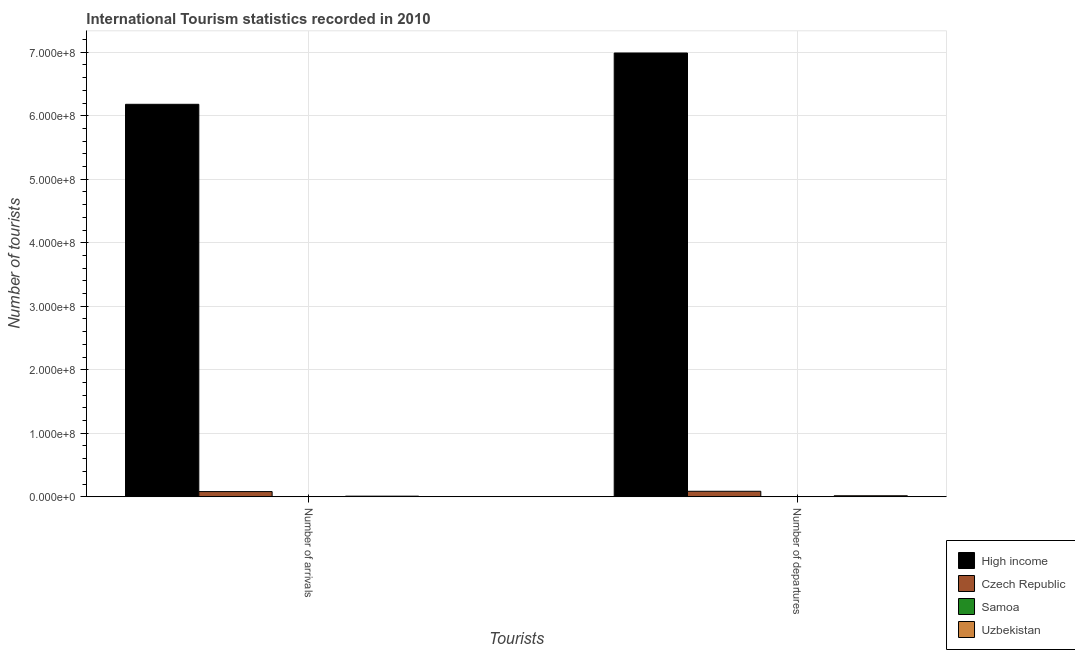Are the number of bars per tick equal to the number of legend labels?
Provide a short and direct response. Yes. How many bars are there on the 2nd tick from the right?
Ensure brevity in your answer.  4. What is the label of the 1st group of bars from the left?
Ensure brevity in your answer.  Number of arrivals. What is the number of tourist departures in High income?
Offer a very short reply. 6.99e+08. Across all countries, what is the maximum number of tourist arrivals?
Ensure brevity in your answer.  6.18e+08. Across all countries, what is the minimum number of tourist arrivals?
Provide a short and direct response. 1.22e+05. In which country was the number of tourist arrivals minimum?
Your answer should be compact. Samoa. What is the total number of tourist arrivals in the graph?
Make the answer very short. 6.27e+08. What is the difference between the number of tourist departures in Czech Republic and that in Uzbekistan?
Ensure brevity in your answer.  7.06e+06. What is the difference between the number of tourist arrivals in Czech Republic and the number of tourist departures in Uzbekistan?
Provide a succinct answer. 6.58e+06. What is the average number of tourist departures per country?
Offer a very short reply. 1.77e+08. What is the difference between the number of tourist departures and number of tourist arrivals in High income?
Provide a short and direct response. 8.08e+07. What is the ratio of the number of tourist departures in Samoa to that in High income?
Provide a short and direct response. 8.01308172830828e-5. Is the number of tourist arrivals in High income less than that in Czech Republic?
Give a very brief answer. No. What does the 4th bar from the left in Number of departures represents?
Keep it short and to the point. Uzbekistan. What does the 3rd bar from the right in Number of departures represents?
Your response must be concise. Czech Republic. How many bars are there?
Keep it short and to the point. 8. How many countries are there in the graph?
Make the answer very short. 4. Does the graph contain grids?
Offer a very short reply. Yes. Where does the legend appear in the graph?
Offer a very short reply. Bottom right. How many legend labels are there?
Ensure brevity in your answer.  4. How are the legend labels stacked?
Provide a succinct answer. Vertical. What is the title of the graph?
Provide a succinct answer. International Tourism statistics recorded in 2010. Does "Mongolia" appear as one of the legend labels in the graph?
Provide a short and direct response. No. What is the label or title of the X-axis?
Provide a succinct answer. Tourists. What is the label or title of the Y-axis?
Make the answer very short. Number of tourists. What is the Number of tourists in High income in Number of arrivals?
Give a very brief answer. 6.18e+08. What is the Number of tourists in Czech Republic in Number of arrivals?
Offer a very short reply. 8.18e+06. What is the Number of tourists in Samoa in Number of arrivals?
Provide a short and direct response. 1.22e+05. What is the Number of tourists of Uzbekistan in Number of arrivals?
Offer a terse response. 9.75e+05. What is the Number of tourists in High income in Number of departures?
Offer a terse response. 6.99e+08. What is the Number of tourists of Czech Republic in Number of departures?
Keep it short and to the point. 8.67e+06. What is the Number of tourists of Samoa in Number of departures?
Ensure brevity in your answer.  5.60e+04. What is the Number of tourists in Uzbekistan in Number of departures?
Offer a terse response. 1.61e+06. Across all Tourists, what is the maximum Number of tourists in High income?
Offer a terse response. 6.99e+08. Across all Tourists, what is the maximum Number of tourists of Czech Republic?
Provide a short and direct response. 8.67e+06. Across all Tourists, what is the maximum Number of tourists in Samoa?
Ensure brevity in your answer.  1.22e+05. Across all Tourists, what is the maximum Number of tourists in Uzbekistan?
Your answer should be compact. 1.61e+06. Across all Tourists, what is the minimum Number of tourists in High income?
Ensure brevity in your answer.  6.18e+08. Across all Tourists, what is the minimum Number of tourists in Czech Republic?
Keep it short and to the point. 8.18e+06. Across all Tourists, what is the minimum Number of tourists of Samoa?
Your answer should be compact. 5.60e+04. Across all Tourists, what is the minimum Number of tourists of Uzbekistan?
Your answer should be compact. 9.75e+05. What is the total Number of tourists in High income in the graph?
Ensure brevity in your answer.  1.32e+09. What is the total Number of tourists of Czech Republic in the graph?
Your response must be concise. 1.69e+07. What is the total Number of tourists of Samoa in the graph?
Keep it short and to the point. 1.78e+05. What is the total Number of tourists of Uzbekistan in the graph?
Offer a terse response. 2.58e+06. What is the difference between the Number of tourists of High income in Number of arrivals and that in Number of departures?
Give a very brief answer. -8.08e+07. What is the difference between the Number of tourists in Czech Republic in Number of arrivals and that in Number of departures?
Offer a very short reply. -4.88e+05. What is the difference between the Number of tourists in Samoa in Number of arrivals and that in Number of departures?
Keep it short and to the point. 6.60e+04. What is the difference between the Number of tourists in Uzbekistan in Number of arrivals and that in Number of departures?
Keep it short and to the point. -6.35e+05. What is the difference between the Number of tourists in High income in Number of arrivals and the Number of tourists in Czech Republic in Number of departures?
Make the answer very short. 6.09e+08. What is the difference between the Number of tourists in High income in Number of arrivals and the Number of tourists in Samoa in Number of departures?
Offer a terse response. 6.18e+08. What is the difference between the Number of tourists in High income in Number of arrivals and the Number of tourists in Uzbekistan in Number of departures?
Your answer should be very brief. 6.16e+08. What is the difference between the Number of tourists of Czech Republic in Number of arrivals and the Number of tourists of Samoa in Number of departures?
Your answer should be compact. 8.13e+06. What is the difference between the Number of tourists in Czech Republic in Number of arrivals and the Number of tourists in Uzbekistan in Number of departures?
Keep it short and to the point. 6.58e+06. What is the difference between the Number of tourists in Samoa in Number of arrivals and the Number of tourists in Uzbekistan in Number of departures?
Give a very brief answer. -1.49e+06. What is the average Number of tourists of High income per Tourists?
Your response must be concise. 6.58e+08. What is the average Number of tourists in Czech Republic per Tourists?
Give a very brief answer. 8.43e+06. What is the average Number of tourists of Samoa per Tourists?
Make the answer very short. 8.90e+04. What is the average Number of tourists of Uzbekistan per Tourists?
Your answer should be compact. 1.29e+06. What is the difference between the Number of tourists of High income and Number of tourists of Czech Republic in Number of arrivals?
Your answer should be very brief. 6.10e+08. What is the difference between the Number of tourists of High income and Number of tourists of Samoa in Number of arrivals?
Make the answer very short. 6.18e+08. What is the difference between the Number of tourists in High income and Number of tourists in Uzbekistan in Number of arrivals?
Offer a very short reply. 6.17e+08. What is the difference between the Number of tourists in Czech Republic and Number of tourists in Samoa in Number of arrivals?
Make the answer very short. 8.06e+06. What is the difference between the Number of tourists of Czech Republic and Number of tourists of Uzbekistan in Number of arrivals?
Ensure brevity in your answer.  7.21e+06. What is the difference between the Number of tourists in Samoa and Number of tourists in Uzbekistan in Number of arrivals?
Offer a very short reply. -8.53e+05. What is the difference between the Number of tourists of High income and Number of tourists of Czech Republic in Number of departures?
Give a very brief answer. 6.90e+08. What is the difference between the Number of tourists of High income and Number of tourists of Samoa in Number of departures?
Ensure brevity in your answer.  6.99e+08. What is the difference between the Number of tourists in High income and Number of tourists in Uzbekistan in Number of departures?
Offer a very short reply. 6.97e+08. What is the difference between the Number of tourists in Czech Republic and Number of tourists in Samoa in Number of departures?
Ensure brevity in your answer.  8.62e+06. What is the difference between the Number of tourists of Czech Republic and Number of tourists of Uzbekistan in Number of departures?
Offer a very short reply. 7.06e+06. What is the difference between the Number of tourists in Samoa and Number of tourists in Uzbekistan in Number of departures?
Your answer should be very brief. -1.55e+06. What is the ratio of the Number of tourists of High income in Number of arrivals to that in Number of departures?
Your answer should be compact. 0.88. What is the ratio of the Number of tourists of Czech Republic in Number of arrivals to that in Number of departures?
Provide a succinct answer. 0.94. What is the ratio of the Number of tourists in Samoa in Number of arrivals to that in Number of departures?
Your answer should be very brief. 2.18. What is the ratio of the Number of tourists in Uzbekistan in Number of arrivals to that in Number of departures?
Provide a succinct answer. 0.61. What is the difference between the highest and the second highest Number of tourists of High income?
Your answer should be compact. 8.08e+07. What is the difference between the highest and the second highest Number of tourists in Czech Republic?
Ensure brevity in your answer.  4.88e+05. What is the difference between the highest and the second highest Number of tourists of Samoa?
Ensure brevity in your answer.  6.60e+04. What is the difference between the highest and the second highest Number of tourists in Uzbekistan?
Ensure brevity in your answer.  6.35e+05. What is the difference between the highest and the lowest Number of tourists of High income?
Keep it short and to the point. 8.08e+07. What is the difference between the highest and the lowest Number of tourists of Czech Republic?
Your answer should be very brief. 4.88e+05. What is the difference between the highest and the lowest Number of tourists of Samoa?
Your answer should be very brief. 6.60e+04. What is the difference between the highest and the lowest Number of tourists of Uzbekistan?
Your answer should be compact. 6.35e+05. 